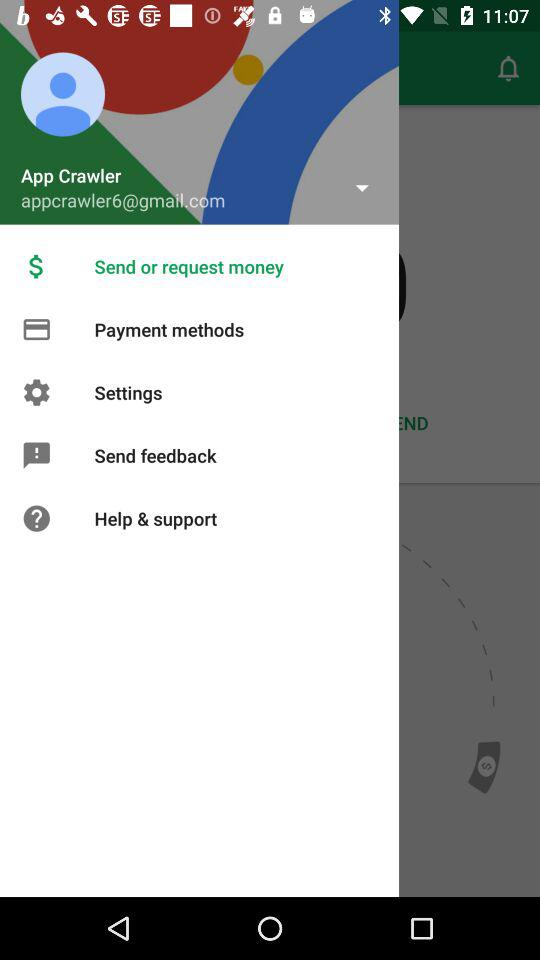What is the email address? The email address is appcrawler6@gmail.com. 